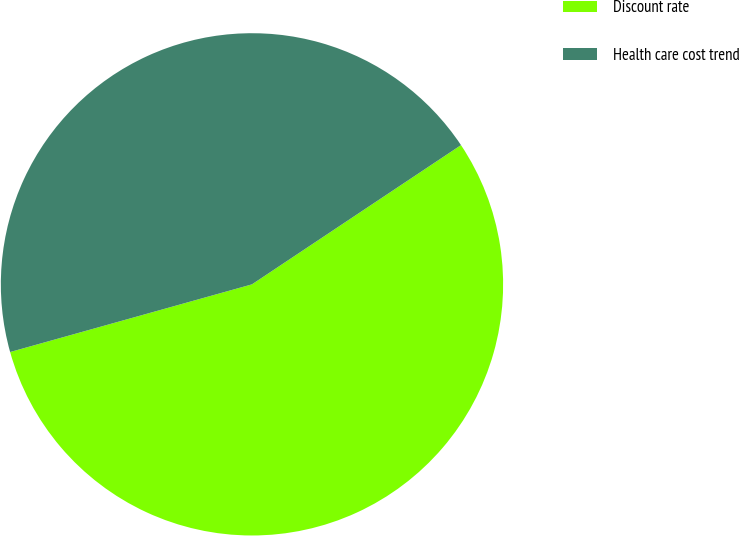Convert chart. <chart><loc_0><loc_0><loc_500><loc_500><pie_chart><fcel>Discount rate<fcel>Health care cost trend<nl><fcel>55.01%<fcel>44.99%<nl></chart> 